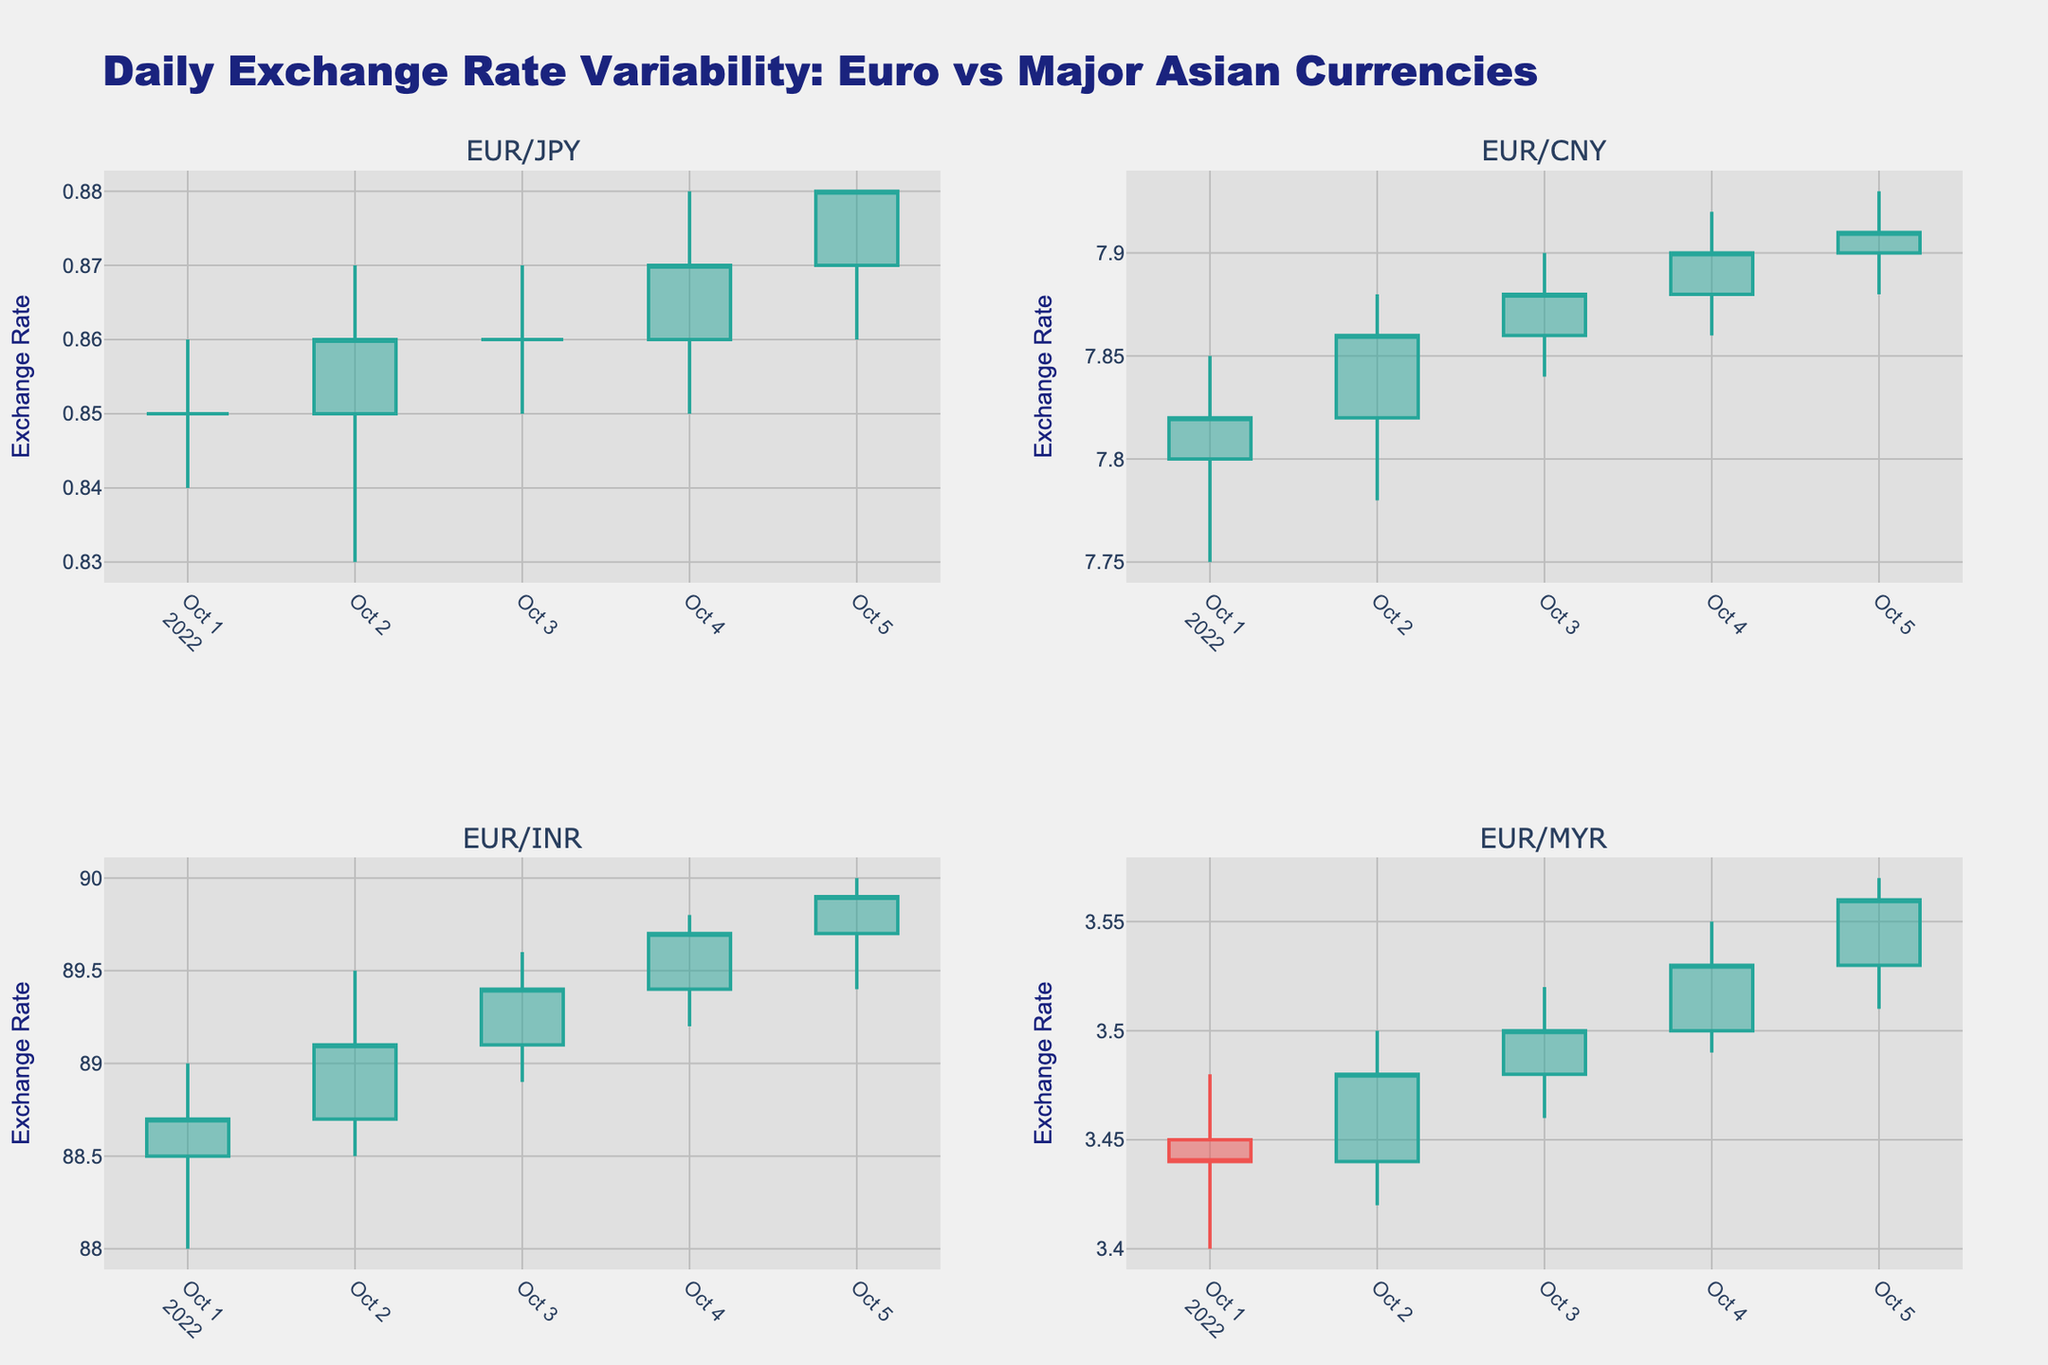How many subplots are in the candlestick plot? The plot has four subplots, each representing Euro exchange rates with different Asian currencies. This is specified in the code with the subplot titles and the layout distribution.
Answer: 4 What is the title of the overall plot? The title of the plot is displayed at the top, reading "Daily Exchange Rate Variability: Euro vs Major Asian Currencies."
Answer: Daily Exchange Rate Variability: Euro vs Major Asian Currencies Which currencies are being compared in the subplots? The subplot titles indicate the currencies being compared: EUR/JPY, EUR/CNY, EUR/INR, and EUR/MYR.
Answer: EUR/JPY, EUR/CNY, EUR/INR, EUR/MYR What's the range of the exchange rate for EUR/JPY on October 3, 2022? On October 3, 2022, the candlestick for EUR/JPY shows a high of 0.87 and a low of 0.85.
Answer: 0.85 to 0.87 Which currency had the highest closing exchange rate on October 5, 2022? On October 5, 2022, examine the closing rates for all subplots. EUR/INR had the highest closing rate of 89.9.
Answer: EUR/INR Compare the exchange rate variability of EUR/CNY and EUR/MYR on October 2, 2022. Which one had a larger range? Check the high and low values for October 2, 2022:
- EUR/CNY: high of 7.88 and low of 7.78 (range: 7.88 - 7.78 = 0.10)
- EUR/MYR: high of 3.50 and low of 3.42 (range: 3.50 - 3.42 = 0.08)
EUR/CNY had a larger range.
Answer: EUR/CNY For EUR/INR, what was the overall trend from October 1, 2022, to October 5, 2022? Look at the closing prices for EUR/INR over the specified dates. The closing prices increased steadily from 88.7 to 89.9, indicating an upward trend.
Answer: Upward trend Determine the average closing price for EUR/CNY over the five-day period. Add the closing prices: 7.82, 7.86, 7.88, 7.90, 7.91 and divide by 5: (7.82 + 7.86 + 7.88 + 7.90 + 7.91)/5 = 7.874.
Answer: 7.874 How does the opening price of EUR/JPY on October 2, 2022, compare to the closing price on October 1, 2022? The opening price of EUR/JPY on October 2, 2022, is 0.85, and the closing price on October 1, 2022, is also 0.85. They are equal.
Answer: Equal Was there any day when EUR/MYR closed at a value lower than its opening price during the five-day period? Examine each candlestick for EUR/MYR:
- October 1: Open 3.45, Close 3.44
On this day, EUR/MYR closed at a value lower than its opening price.
Answer: Yes 